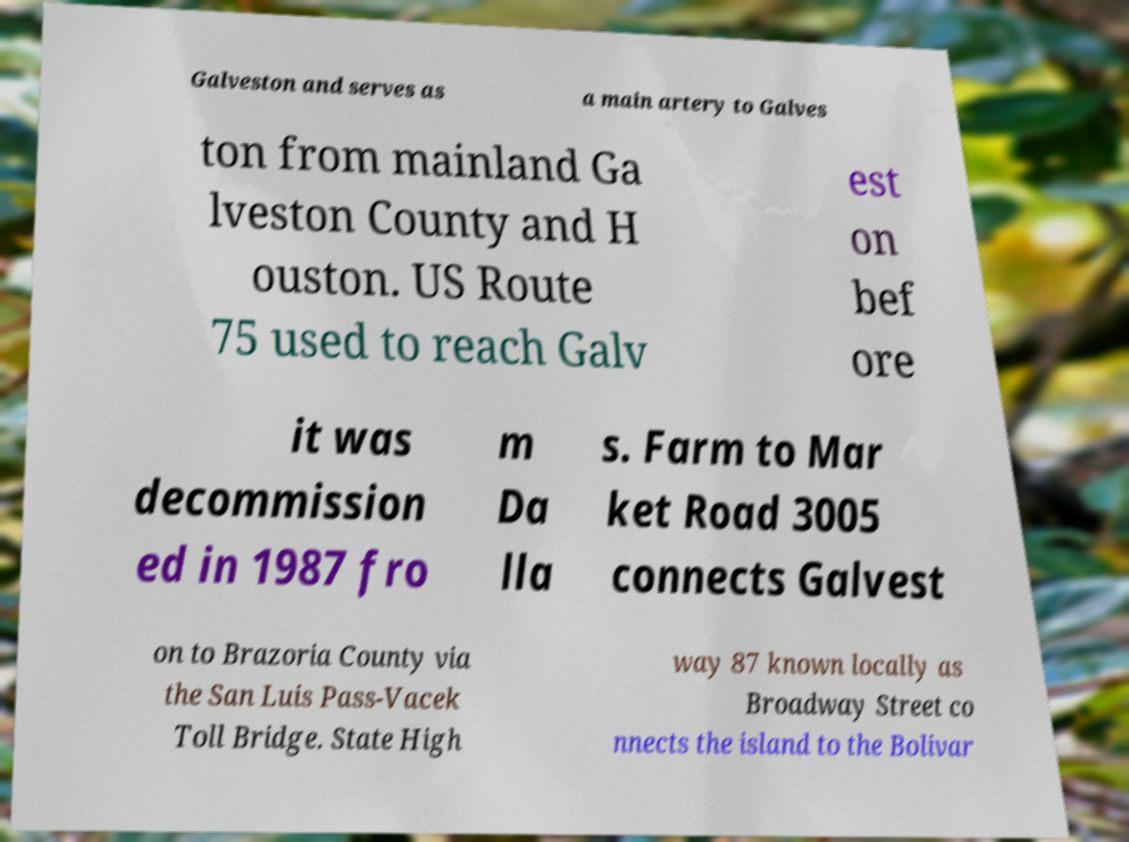What messages or text are displayed in this image? I need them in a readable, typed format. Galveston and serves as a main artery to Galves ton from mainland Ga lveston County and H ouston. US Route 75 used to reach Galv est on bef ore it was decommission ed in 1987 fro m Da lla s. Farm to Mar ket Road 3005 connects Galvest on to Brazoria County via the San Luis Pass-Vacek Toll Bridge. State High way 87 known locally as Broadway Street co nnects the island to the Bolivar 